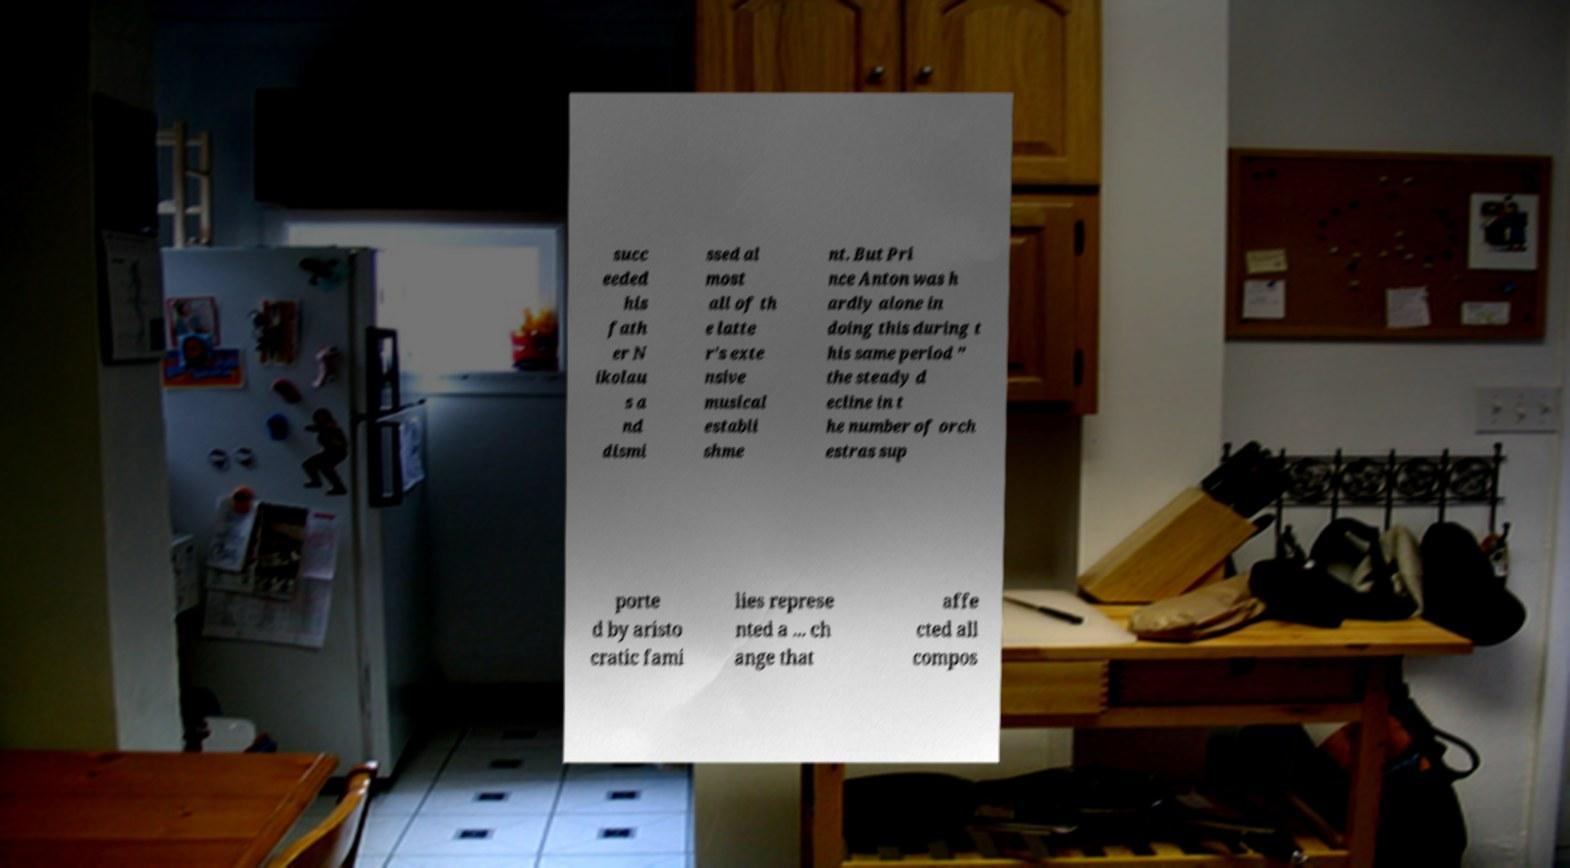Please identify and transcribe the text found in this image. succ eeded his fath er N ikolau s a nd dismi ssed al most all of th e latte r's exte nsive musical establi shme nt. But Pri nce Anton was h ardly alone in doing this during t his same period " the steady d ecline in t he number of orch estras sup porte d by aristo cratic fami lies represe nted a ... ch ange that affe cted all compos 